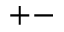Convert formula to latex. <formula><loc_0><loc_0><loc_500><loc_500>+ -</formula> 